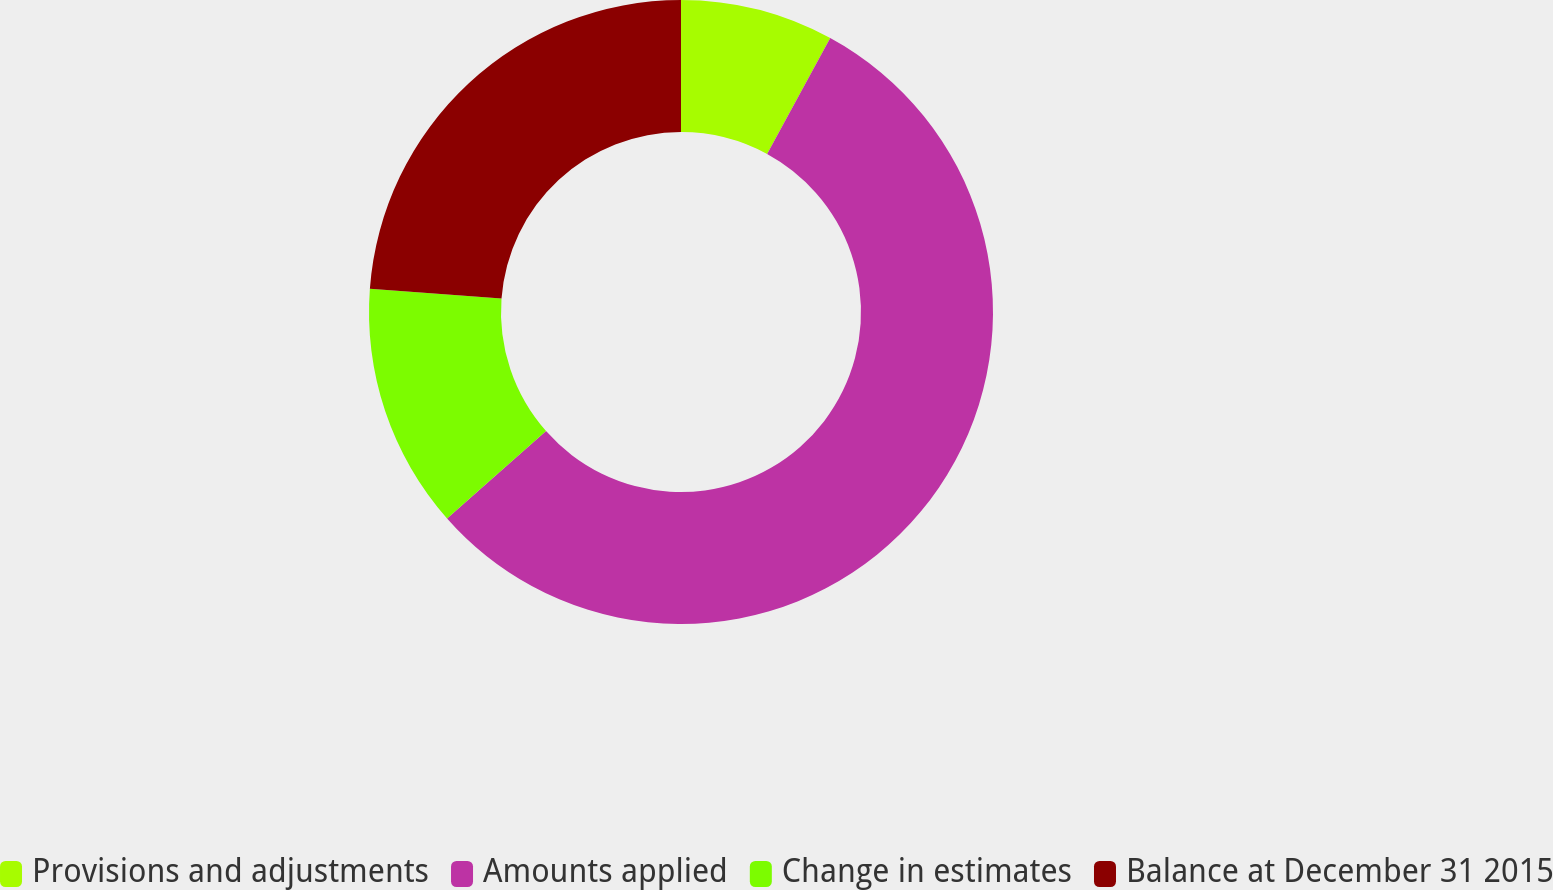<chart> <loc_0><loc_0><loc_500><loc_500><pie_chart><fcel>Provisions and adjustments<fcel>Amounts applied<fcel>Change in estimates<fcel>Balance at December 31 2015<nl><fcel>7.94%<fcel>55.56%<fcel>12.7%<fcel>23.81%<nl></chart> 